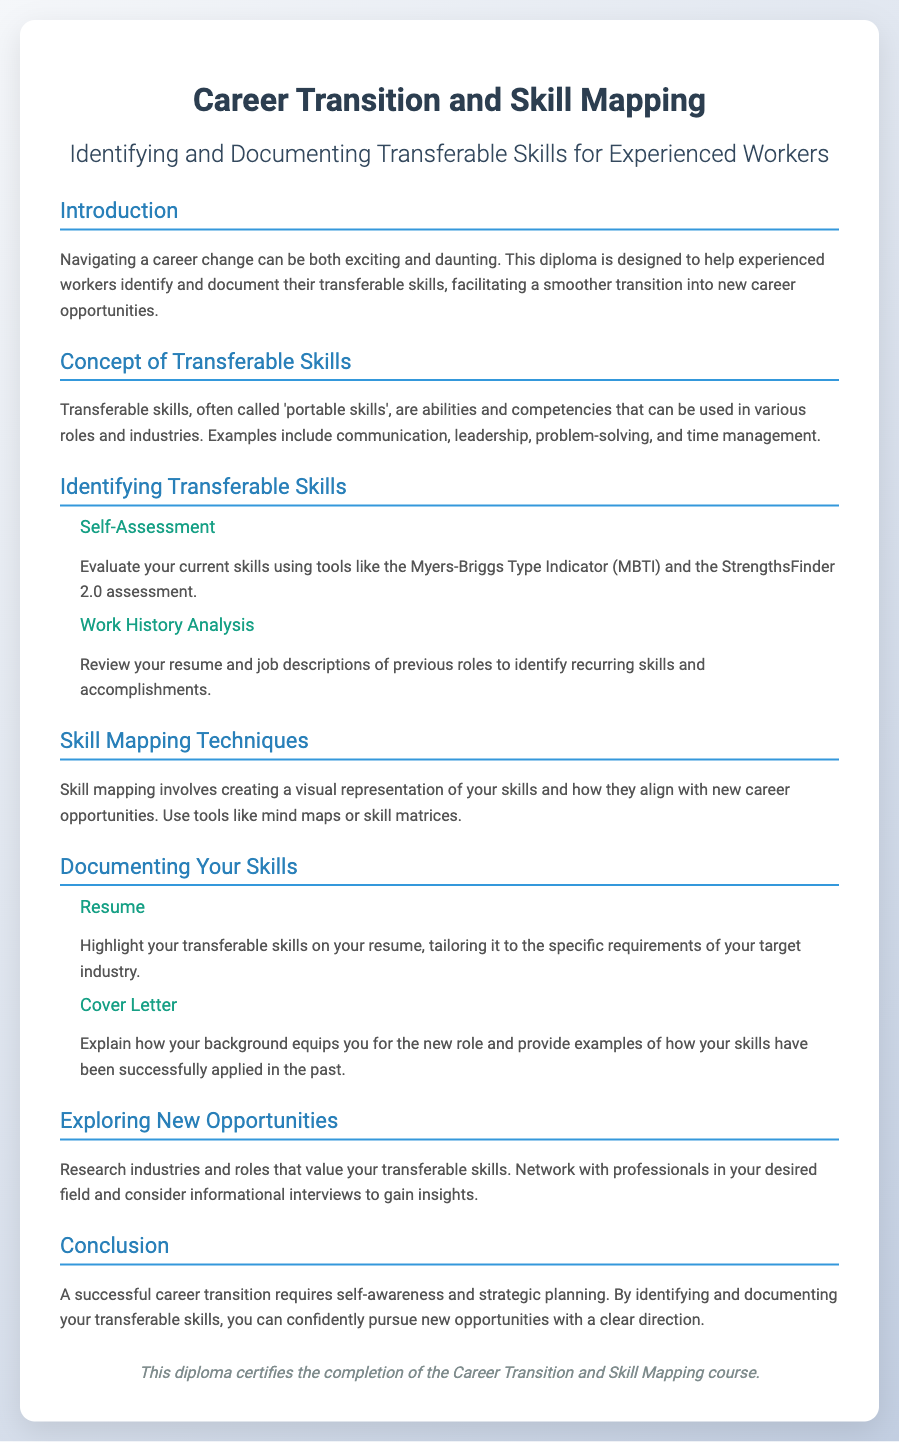What is the title of the diploma? The title of the diploma is stated at the top of the document.
Answer: Career Transition and Skill Mapping What are transferable skills often called? The document defines another term for transferable skills in the section discussing their concept.
Answer: Portable skills What tool is suggested for self-assessment? The self-assessment section mentions specific tools for evaluating skills.
Answer: Myers-Briggs Type Indicator Which document should highlight transferable skills? The section on documenting skills specifies the type of document that should emphasize these skills.
Answer: Resume What is one technique mentioned for skill mapping? The skill mapping techniques section suggests a specific method for visual representation of skills.
Answer: Mind maps What does successful career transition require? The conclusion highlights the essential elements needed for a successful transition.
Answer: Self-awareness and strategic planning What is a recommended activity to explore new opportunities? The exploring new opportunities section suggests an approach for gaining insights into desired fields.
Answer: Networking How can one tailor their resume? The document provides guidance on customizing resumes for a specific purpose.
Answer: To the specific requirements of your target industry 